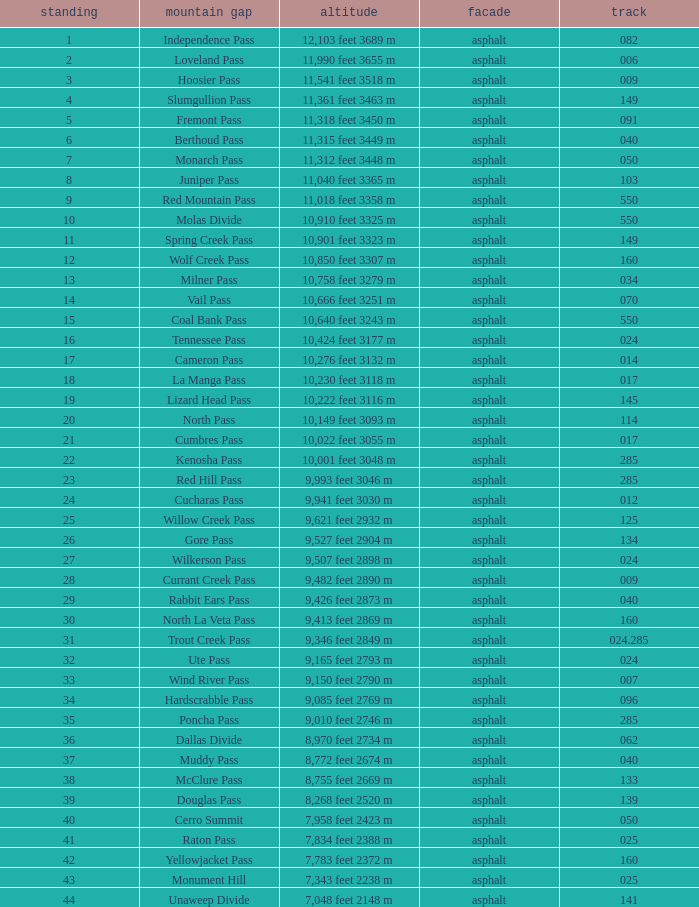What is the Surface of the Route less than 7? Asphalt. 